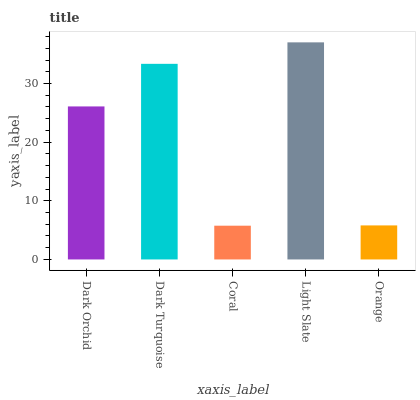Is Coral the minimum?
Answer yes or no. Yes. Is Light Slate the maximum?
Answer yes or no. Yes. Is Dark Turquoise the minimum?
Answer yes or no. No. Is Dark Turquoise the maximum?
Answer yes or no. No. Is Dark Turquoise greater than Dark Orchid?
Answer yes or no. Yes. Is Dark Orchid less than Dark Turquoise?
Answer yes or no. Yes. Is Dark Orchid greater than Dark Turquoise?
Answer yes or no. No. Is Dark Turquoise less than Dark Orchid?
Answer yes or no. No. Is Dark Orchid the high median?
Answer yes or no. Yes. Is Dark Orchid the low median?
Answer yes or no. Yes. Is Orange the high median?
Answer yes or no. No. Is Dark Turquoise the low median?
Answer yes or no. No. 